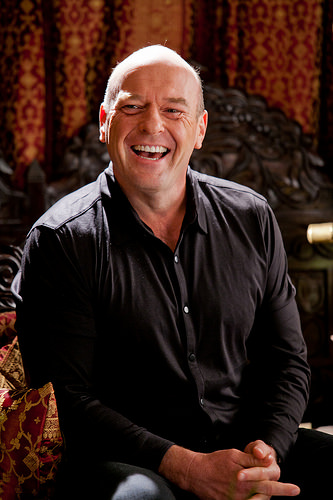<image>
Is the smile to the right of the bald? No. The smile is not to the right of the bald. The horizontal positioning shows a different relationship. 